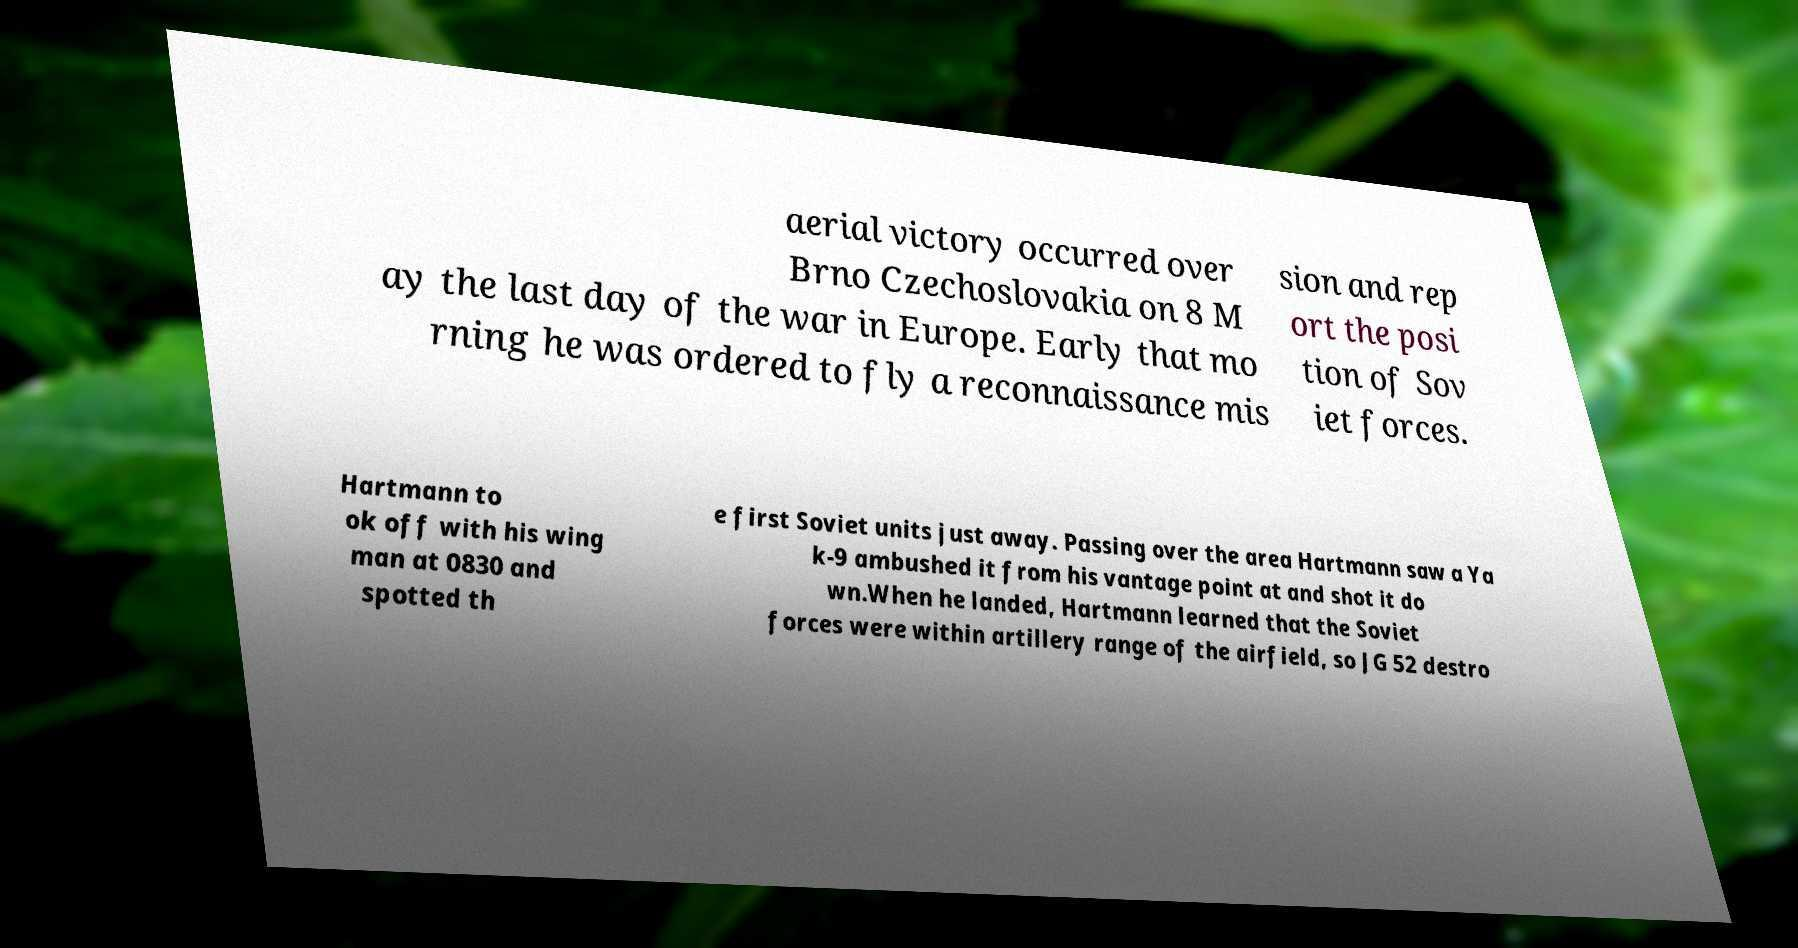There's text embedded in this image that I need extracted. Can you transcribe it verbatim? aerial victory occurred over Brno Czechoslovakia on 8 M ay the last day of the war in Europe. Early that mo rning he was ordered to fly a reconnaissance mis sion and rep ort the posi tion of Sov iet forces. Hartmann to ok off with his wing man at 0830 and spotted th e first Soviet units just away. Passing over the area Hartmann saw a Ya k-9 ambushed it from his vantage point at and shot it do wn.When he landed, Hartmann learned that the Soviet forces were within artillery range of the airfield, so JG 52 destro 